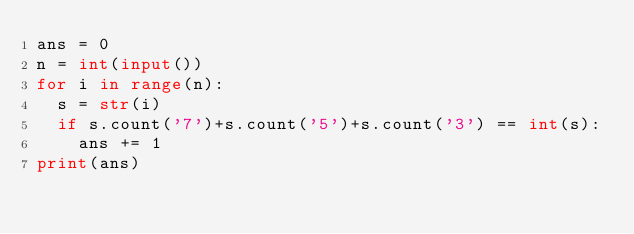<code> <loc_0><loc_0><loc_500><loc_500><_Python_>ans = 0
n = int(input())
for i in range(n):
  s = str(i)
  if s.count('7')+s.count('5')+s.count('3') == int(s):
    ans += 1
print(ans)
</code> 